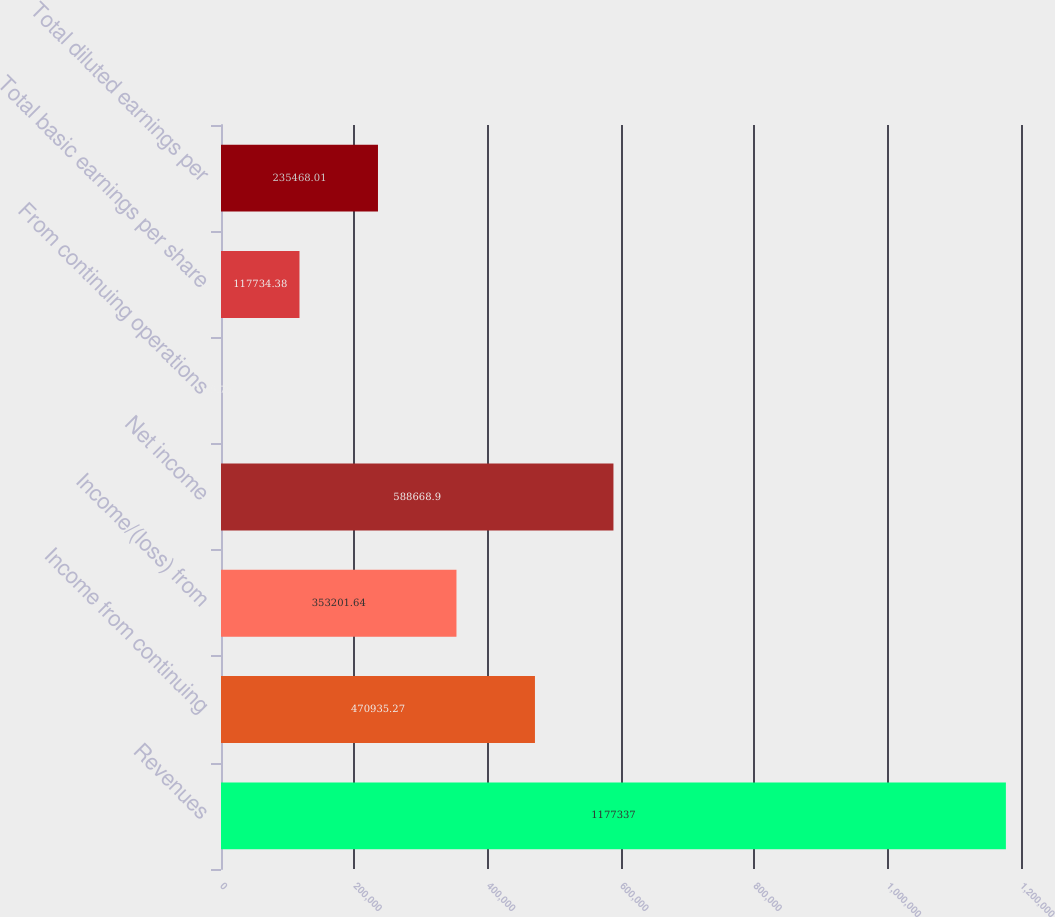Convert chart. <chart><loc_0><loc_0><loc_500><loc_500><bar_chart><fcel>Revenues<fcel>Income from continuing<fcel>Income/(loss) from<fcel>Net income<fcel>From continuing operations<fcel>Total basic earnings per share<fcel>Total diluted earnings per<nl><fcel>1.17734e+06<fcel>470935<fcel>353202<fcel>588669<fcel>0.75<fcel>117734<fcel>235468<nl></chart> 